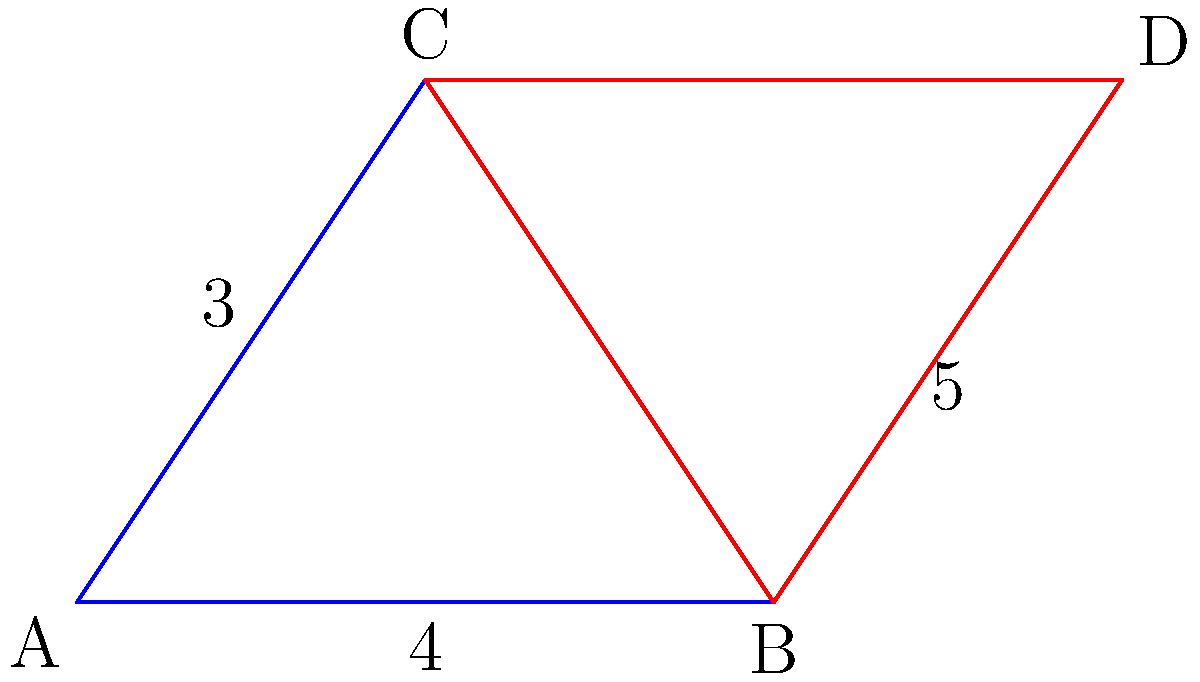In designing a logo for a youth center, you've created two triangles as shown. Triangle ABC (blue) represents "growth," while triangle BCD (red) represents "community." If AB = 4 units, BC = 3 units, and BD = 5 units, are these triangles congruent? If so, state the congruence criterion. Let's approach this step-by-step:

1) For triangles to be congruent, they must have all corresponding sides and angles equal.

2) We're given:
   AB = 4 units
   BC = 3 units (shared side)
   BD = 5 units

3) Let's check if we can apply any congruence criterion:

   a) Side-Side-Side (SSS): We need all three sides of each triangle to be equal.
   b) Side-Angle-Side (SAS): We need two sides and the included angle to be equal.
   c) Angle-Side-Angle (ASA): We need two angles and the included side to be equal.

4) We have two sides of each triangle:
   Triangle ABC: AB = 4, BC = 3
   Triangle BCD: BD = 5, BC = 3

5) Notice that BC is a shared side, so it's equal in both triangles.

6) We don't have information about any angles, so we can't use ASA or SAS.

7) However, we can use the SSS criterion if we can prove that AC = CD.

8) We can do this using the Pythagorean theorem:

   For triangle ABC: $AC^2 = AB^2 + BC^2 = 4^2 + 3^2 = 16 + 9 = 25$
                     $AC = 5$

   For triangle BCD: We're given that BD = 5, which is equal to AC.

9) Therefore, we have:
   Triangle ABC: AB = 4, BC = 3, AC = 5
   Triangle BCD: BD = 5, BC = 3, CD = 5 (CD is the same as AC)

10) All corresponding sides are equal, so the triangles are congruent by the SSS criterion.
Answer: Yes, SSS 